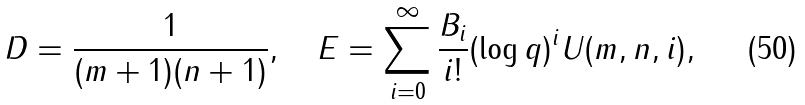<formula> <loc_0><loc_0><loc_500><loc_500>D = \frac { 1 } { ( m + 1 ) ( n + 1 ) } , \quad E = \sum _ { i = 0 } ^ { \infty } \frac { B _ { i } } { i ! } ( \log q ) ^ { i } U ( m , n , i ) ,</formula> 